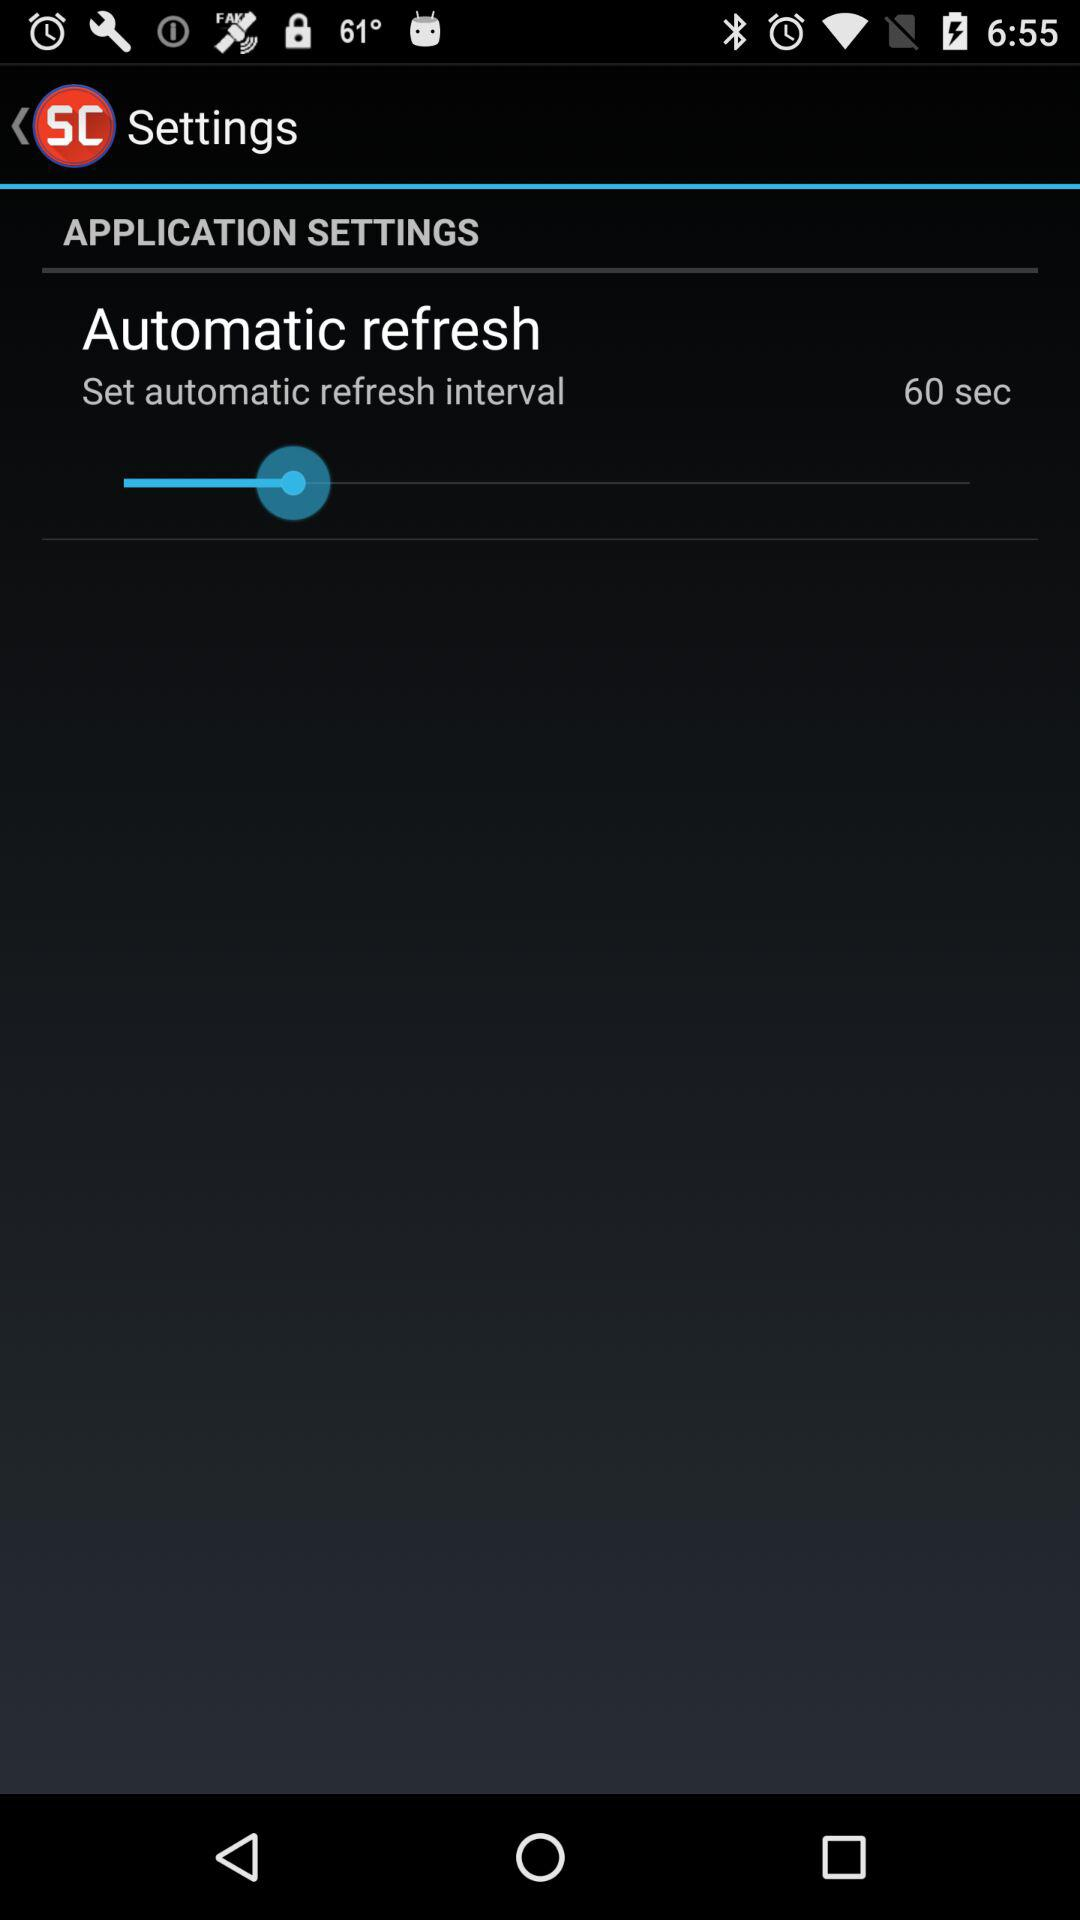How long is the current automatic refresh interval?
Answer the question using a single word or phrase. 60 sec 